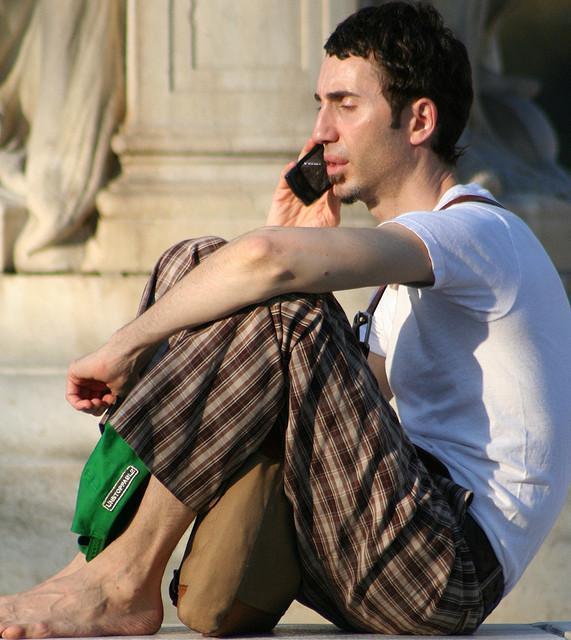How many people are in the photo?
Give a very brief answer. 1. 